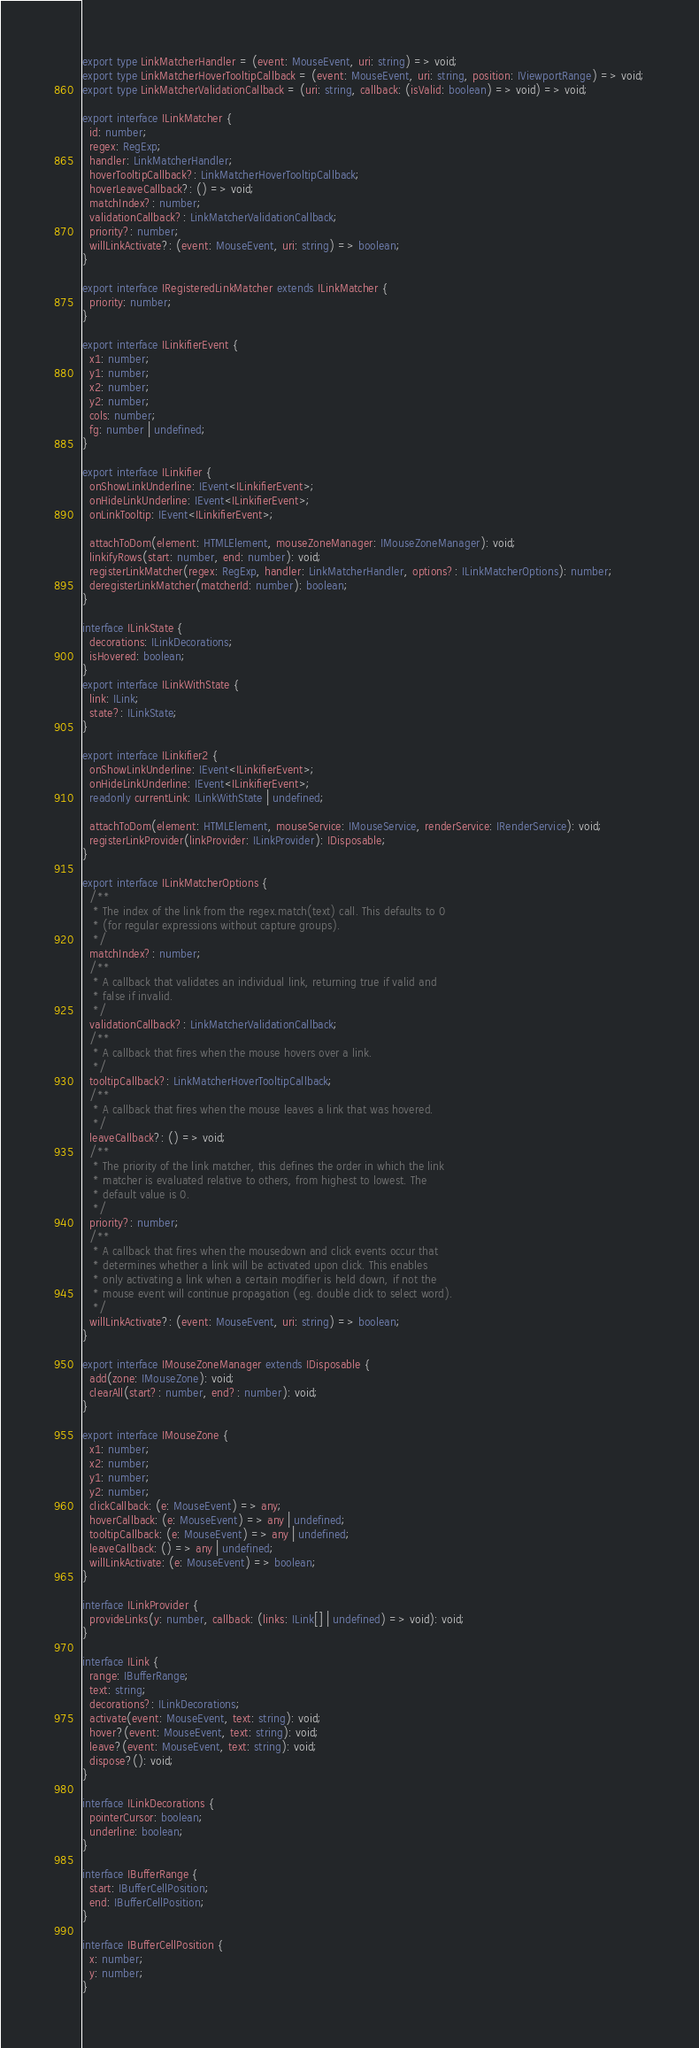<code> <loc_0><loc_0><loc_500><loc_500><_TypeScript_>
export type LinkMatcherHandler = (event: MouseEvent, uri: string) => void;
export type LinkMatcherHoverTooltipCallback = (event: MouseEvent, uri: string, position: IViewportRange) => void;
export type LinkMatcherValidationCallback = (uri: string, callback: (isValid: boolean) => void) => void;

export interface ILinkMatcher {
  id: number;
  regex: RegExp;
  handler: LinkMatcherHandler;
  hoverTooltipCallback?: LinkMatcherHoverTooltipCallback;
  hoverLeaveCallback?: () => void;
  matchIndex?: number;
  validationCallback?: LinkMatcherValidationCallback;
  priority?: number;
  willLinkActivate?: (event: MouseEvent, uri: string) => boolean;
}

export interface IRegisteredLinkMatcher extends ILinkMatcher {
  priority: number;
}

export interface ILinkifierEvent {
  x1: number;
  y1: number;
  x2: number;
  y2: number;
  cols: number;
  fg: number | undefined;
}

export interface ILinkifier {
  onShowLinkUnderline: IEvent<ILinkifierEvent>;
  onHideLinkUnderline: IEvent<ILinkifierEvent>;
  onLinkTooltip: IEvent<ILinkifierEvent>;

  attachToDom(element: HTMLElement, mouseZoneManager: IMouseZoneManager): void;
  linkifyRows(start: number, end: number): void;
  registerLinkMatcher(regex: RegExp, handler: LinkMatcherHandler, options?: ILinkMatcherOptions): number;
  deregisterLinkMatcher(matcherId: number): boolean;
}

interface ILinkState {
  decorations: ILinkDecorations;
  isHovered: boolean;
}
export interface ILinkWithState {
  link: ILink;
  state?: ILinkState;
}

export interface ILinkifier2 {
  onShowLinkUnderline: IEvent<ILinkifierEvent>;
  onHideLinkUnderline: IEvent<ILinkifierEvent>;
  readonly currentLink: ILinkWithState | undefined;

  attachToDom(element: HTMLElement, mouseService: IMouseService, renderService: IRenderService): void;
  registerLinkProvider(linkProvider: ILinkProvider): IDisposable;
}

export interface ILinkMatcherOptions {
  /**
   * The index of the link from the regex.match(text) call. This defaults to 0
   * (for regular expressions without capture groups).
   */
  matchIndex?: number;
  /**
   * A callback that validates an individual link, returning true if valid and
   * false if invalid.
   */
  validationCallback?: LinkMatcherValidationCallback;
  /**
   * A callback that fires when the mouse hovers over a link.
   */
  tooltipCallback?: LinkMatcherHoverTooltipCallback;
  /**
   * A callback that fires when the mouse leaves a link that was hovered.
   */
  leaveCallback?: () => void;
  /**
   * The priority of the link matcher, this defines the order in which the link
   * matcher is evaluated relative to others, from highest to lowest. The
   * default value is 0.
   */
  priority?: number;
  /**
   * A callback that fires when the mousedown and click events occur that
   * determines whether a link will be activated upon click. This enables
   * only activating a link when a certain modifier is held down, if not the
   * mouse event will continue propagation (eg. double click to select word).
   */
  willLinkActivate?: (event: MouseEvent, uri: string) => boolean;
}

export interface IMouseZoneManager extends IDisposable {
  add(zone: IMouseZone): void;
  clearAll(start?: number, end?: number): void;
}

export interface IMouseZone {
  x1: number;
  x2: number;
  y1: number;
  y2: number;
  clickCallback: (e: MouseEvent) => any;
  hoverCallback: (e: MouseEvent) => any | undefined;
  tooltipCallback: (e: MouseEvent) => any | undefined;
  leaveCallback: () => any | undefined;
  willLinkActivate: (e: MouseEvent) => boolean;
}

interface ILinkProvider {
  provideLinks(y: number, callback: (links: ILink[] | undefined) => void): void;
}

interface ILink {
  range: IBufferRange;
  text: string;
  decorations?: ILinkDecorations;
  activate(event: MouseEvent, text: string): void;
  hover?(event: MouseEvent, text: string): void;
  leave?(event: MouseEvent, text: string): void;
  dispose?(): void;
}

interface ILinkDecorations {
  pointerCursor: boolean;
  underline: boolean;
}

interface IBufferRange {
  start: IBufferCellPosition;
  end: IBufferCellPosition;
}

interface IBufferCellPosition {
  x: number;
  y: number;
}
</code> 